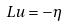<formula> <loc_0><loc_0><loc_500><loc_500>L u = - \eta</formula> 